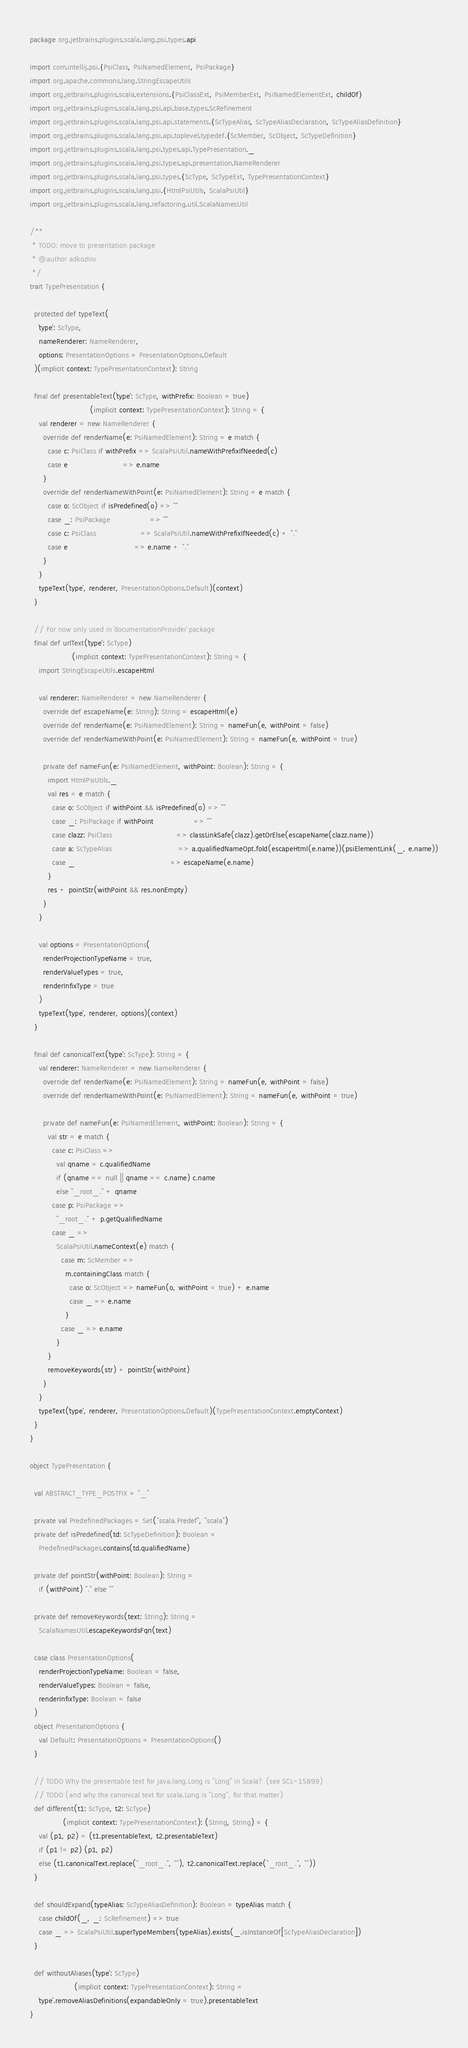<code> <loc_0><loc_0><loc_500><loc_500><_Scala_>package org.jetbrains.plugins.scala.lang.psi.types.api

import com.intellij.psi.{PsiClass, PsiNamedElement, PsiPackage}
import org.apache.commons.lang.StringEscapeUtils
import org.jetbrains.plugins.scala.extensions.{PsiClassExt, PsiMemberExt, PsiNamedElementExt, childOf}
import org.jetbrains.plugins.scala.lang.psi.api.base.types.ScRefinement
import org.jetbrains.plugins.scala.lang.psi.api.statements.{ScTypeAlias, ScTypeAliasDeclaration, ScTypeAliasDefinition}
import org.jetbrains.plugins.scala.lang.psi.api.toplevel.typedef.{ScMember, ScObject, ScTypeDefinition}
import org.jetbrains.plugins.scala.lang.psi.types.api.TypePresentation._
import org.jetbrains.plugins.scala.lang.psi.types.api.presentation.NameRenderer
import org.jetbrains.plugins.scala.lang.psi.types.{ScType, ScTypeExt, TypePresentationContext}
import org.jetbrains.plugins.scala.lang.psi.{HtmlPsiUtils, ScalaPsiUtil}
import org.jetbrains.plugins.scala.lang.refactoring.util.ScalaNamesUtil

/**
 * TODO: move to presentation package
 * @author adkozlov
 */
trait TypePresentation {

  protected def typeText(
    `type`: ScType,
    nameRenderer: NameRenderer,
    options: PresentationOptions = PresentationOptions.Default
  )(implicit context: TypePresentationContext): String

  final def presentableText(`type`: ScType, withPrefix: Boolean = true)
                           (implicit context: TypePresentationContext): String = {
    val renderer = new NameRenderer {
      override def renderName(e: PsiNamedElement): String = e match {
        case c: PsiClass if withPrefix => ScalaPsiUtil.nameWithPrefixIfNeeded(c)
        case e                         => e.name
      }
      override def renderNameWithPoint(e: PsiNamedElement): String = e match {
        case o: ScObject if isPredefined(o) => ""
        case _: PsiPackage                  => ""
        case c: PsiClass                    => ScalaPsiUtil.nameWithPrefixIfNeeded(c) + "."
        case e                              => e.name + "."
      }
    }
    typeText(`type`, renderer, PresentationOptions.Default)(context)
  }

  // For now only used in `documentationProvider` package
  final def urlText(`type`: ScType)
                   (implicit context: TypePresentationContext): String = {
    import StringEscapeUtils.escapeHtml

    val renderer: NameRenderer = new NameRenderer {
      override def escapeName(e: String): String = escapeHtml(e)
      override def renderName(e: PsiNamedElement): String = nameFun(e, withPoint = false)
      override def renderNameWithPoint(e: PsiNamedElement): String = nameFun(e, withPoint = true)

      private def nameFun(e: PsiNamedElement, withPoint: Boolean): String = {
        import HtmlPsiUtils._
        val res = e match {
          case o: ScObject if withPoint && isPredefined(o) => ""
          case _: PsiPackage if withPoint                  => ""
          case clazz: PsiClass                             => classLinkSafe(clazz).getOrElse(escapeName(clazz.name))
          case a: ScTypeAlias                              => a.qualifiedNameOpt.fold(escapeHtml(e.name))(psiElementLink(_, e.name))
          case _                                           => escapeName(e.name)
        }
        res + pointStr(withPoint && res.nonEmpty)
      }
    }

    val options = PresentationOptions(
      renderProjectionTypeName = true,
      renderValueTypes = true,
      renderInfixType = true
    )
    typeText(`type`, renderer, options)(context)
  }

  final def canonicalText(`type`: ScType): String = {
    val renderer: NameRenderer = new NameRenderer {
      override def renderName(e: PsiNamedElement): String = nameFun(e, withPoint = false)
      override def renderNameWithPoint(e: PsiNamedElement): String = nameFun(e, withPoint = true)

      private def nameFun(e: PsiNamedElement, withPoint: Boolean): String = {
        val str = e match {
          case c: PsiClass =>
            val qname = c.qualifiedName
            if (qname == null || qname == c.name) c.name
            else "_root_." + qname
          case p: PsiPackage =>
            "_root_." + p.getQualifiedName
          case _ =>
            ScalaPsiUtil.nameContext(e) match {
              case m: ScMember =>
                m.containingClass match {
                  case o: ScObject => nameFun(o, withPoint = true) + e.name
                  case _ => e.name
                }
              case _ => e.name
            }
        }
        removeKeywords(str) + pointStr(withPoint)
      }
    }
    typeText(`type`, renderer, PresentationOptions.Default)(TypePresentationContext.emptyContext)
  }
}

object TypePresentation {

  val ABSTRACT_TYPE_POSTFIX = "_"

  private val PredefinedPackages = Set("scala.Predef", "scala")
  private def isPredefined(td: ScTypeDefinition): Boolean =
    PredefinedPackages.contains(td.qualifiedName)

  private def pointStr(withPoint: Boolean): String =
    if (withPoint) "." else ""

  private def removeKeywords(text: String): String =
    ScalaNamesUtil.escapeKeywordsFqn(text)

  case class PresentationOptions(
    renderProjectionTypeName: Boolean = false,
    renderValueTypes: Boolean = false,
    renderInfixType: Boolean = false
  )
  object PresentationOptions {
    val Default: PresentationOptions = PresentationOptions()
  }

  // TODO Why the presentable text for java.lang.Long is "Long" in Scala? (see SCL-15899)
  // TODO (and why the canonical text for scala.Long is "Long", for that matter)
  def different(t1: ScType, t2: ScType)
               (implicit context: TypePresentationContext): (String, String) = {
    val (p1, p2) = (t1.presentableText, t2.presentableText)
    if (p1 != p2) (p1, p2)
    else (t1.canonicalText.replace("_root_.", ""), t2.canonicalText.replace("_root_.", ""))
  }

  def shouldExpand(typeAlias: ScTypeAliasDefinition): Boolean = typeAlias match {
    case childOf(_, _: ScRefinement) => true
    case _ => ScalaPsiUtil.superTypeMembers(typeAlias).exists(_.isInstanceOf[ScTypeAliasDeclaration])
  }

  def withoutAliases(`type`: ScType)
                    (implicit context: TypePresentationContext): String =
    `type`.removeAliasDefinitions(expandableOnly = true).presentableText
}</code> 